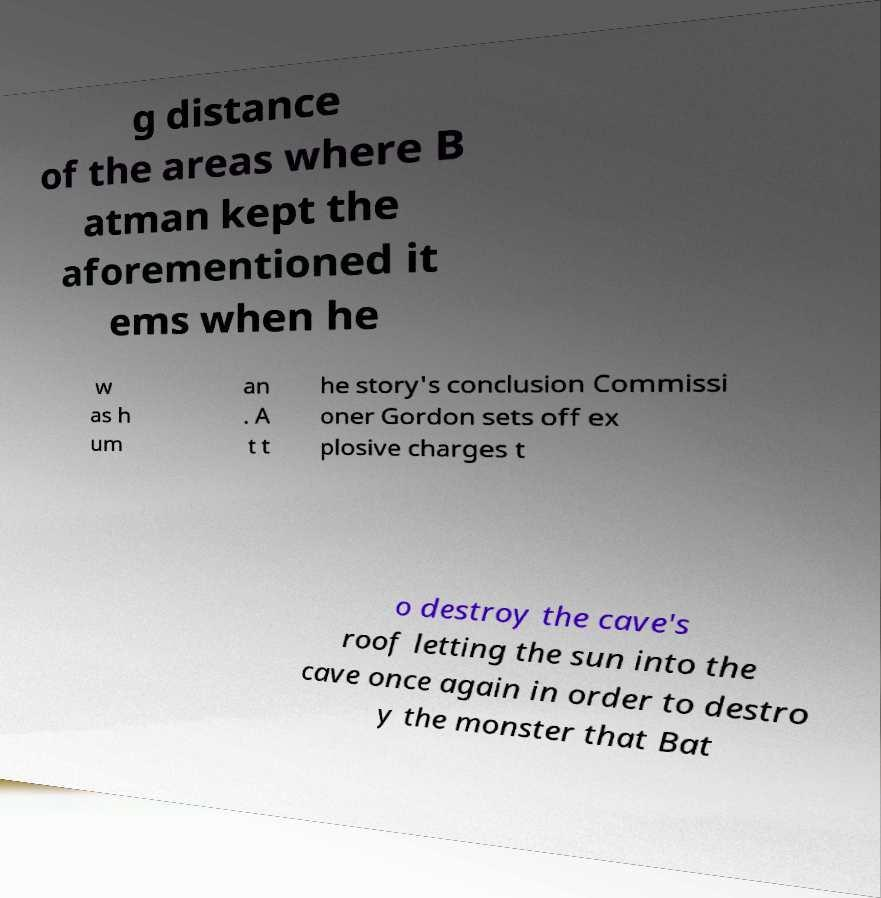Could you extract and type out the text from this image? g distance of the areas where B atman kept the aforementioned it ems when he w as h um an . A t t he story's conclusion Commissi oner Gordon sets off ex plosive charges t o destroy the cave's roof letting the sun into the cave once again in order to destro y the monster that Bat 